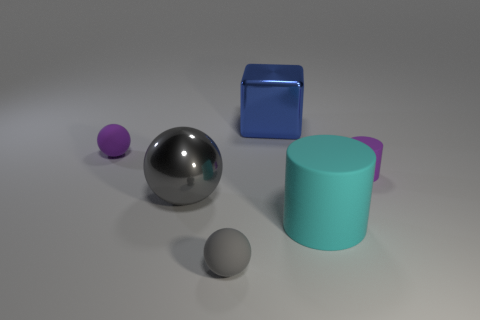The matte object that is the same size as the blue block is what color?
Provide a short and direct response. Cyan. How many things are tiny matte things or gray spheres?
Offer a very short reply. 4. What size is the gray ball on the left side of the rubber ball in front of the small rubber object on the left side of the big gray metallic thing?
Your answer should be very brief. Large. What number of matte objects have the same color as the big sphere?
Your answer should be very brief. 1. How many large balls are the same material as the blue cube?
Offer a very short reply. 1. How many objects are either red rubber balls or purple objects that are on the left side of the big sphere?
Your answer should be very brief. 1. The rubber thing that is behind the purple thing in front of the purple object to the left of the blue object is what color?
Offer a very short reply. Purple. There is a matte thing that is in front of the cyan cylinder; how big is it?
Ensure brevity in your answer.  Small. What number of small things are yellow matte blocks or cyan cylinders?
Make the answer very short. 0. What color is the matte object that is both behind the large matte cylinder and to the left of the big blue object?
Your answer should be compact. Purple. 